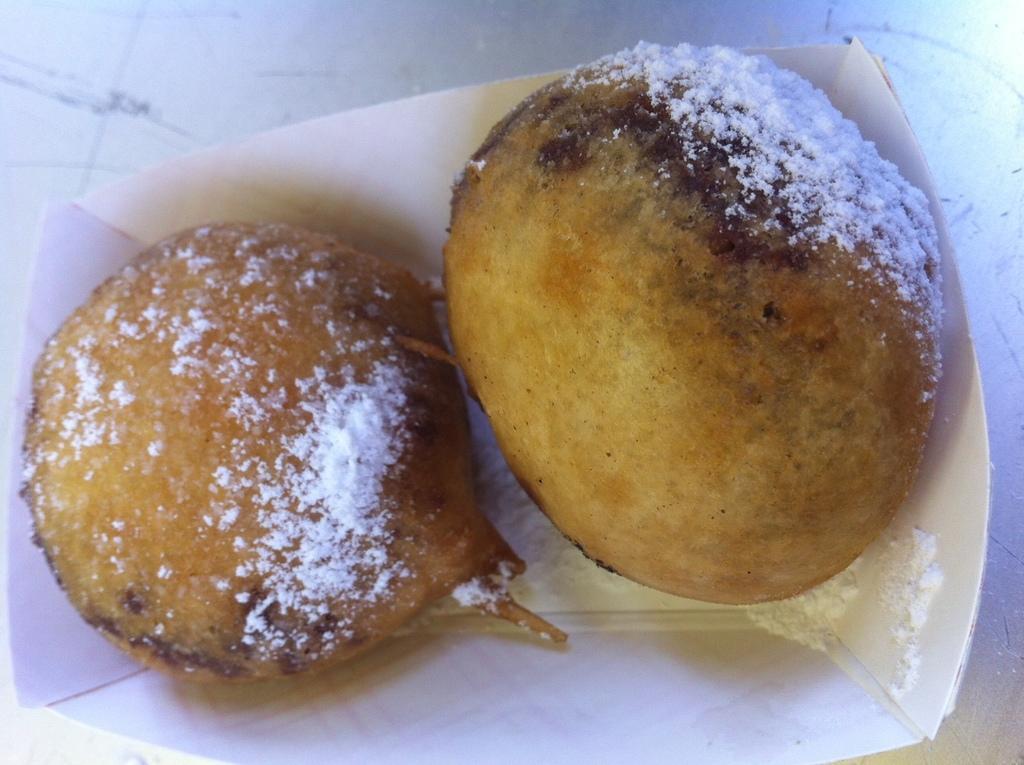How would you summarize this image in a sentence or two? In this image there is a paper cup which has some food in it. On the food there is white colour powder. 